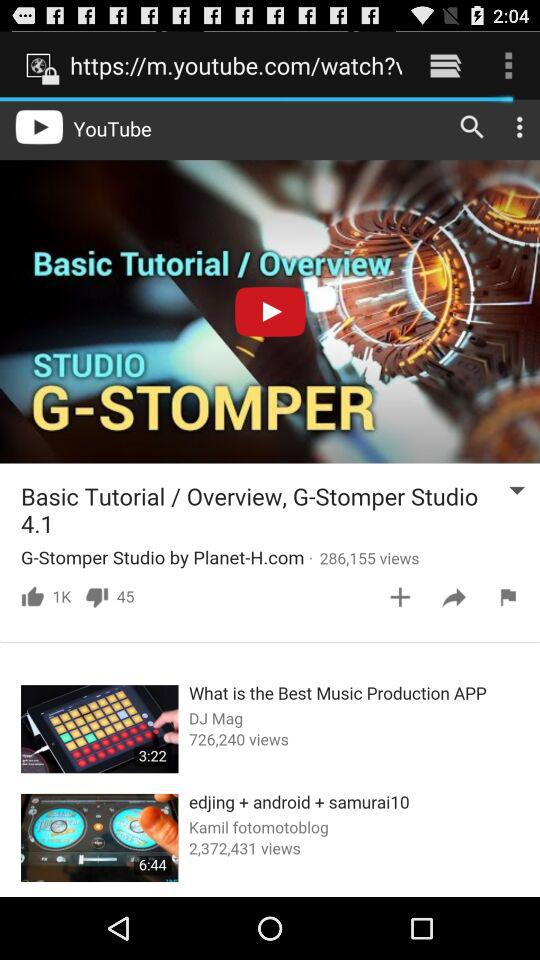Who is the artist of the "What is the Best Music Production APP" video? The artist is "DJ Mag". 